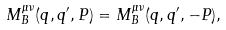<formula> <loc_0><loc_0><loc_500><loc_500>M ^ { \mu \nu } _ { B } ( q , q ^ { \prime } , P ) = M ^ { \mu \nu } _ { B } ( q , q ^ { \prime } , - P ) ,</formula> 